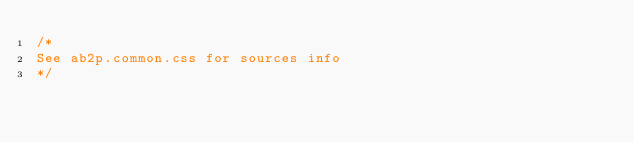Convert code to text. <code><loc_0><loc_0><loc_500><loc_500><_CSS_>/*
See ab2p.common.css for sources info
*/</code> 